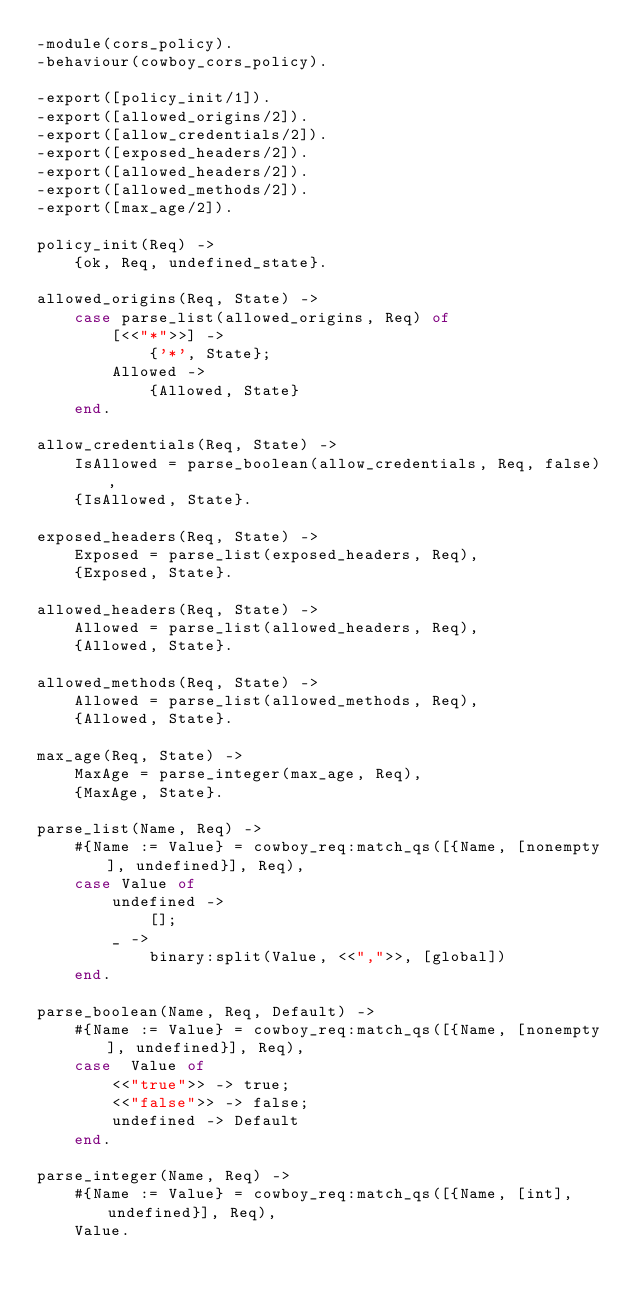<code> <loc_0><loc_0><loc_500><loc_500><_Erlang_>-module(cors_policy).
-behaviour(cowboy_cors_policy).

-export([policy_init/1]).
-export([allowed_origins/2]).
-export([allow_credentials/2]).
-export([exposed_headers/2]).
-export([allowed_headers/2]).
-export([allowed_methods/2]).
-export([max_age/2]).

policy_init(Req) ->
    {ok, Req, undefined_state}.

allowed_origins(Req, State) ->
    case parse_list(allowed_origins, Req) of
        [<<"*">>] ->
            {'*', State};
        Allowed ->
            {Allowed, State}
    end.

allow_credentials(Req, State) ->
    IsAllowed = parse_boolean(allow_credentials, Req, false),
    {IsAllowed, State}.

exposed_headers(Req, State) ->
    Exposed = parse_list(exposed_headers, Req),
    {Exposed, State}.

allowed_headers(Req, State) ->
    Allowed = parse_list(allowed_headers, Req),
    {Allowed, State}.

allowed_methods(Req, State) ->
    Allowed = parse_list(allowed_methods, Req),
    {Allowed, State}.

max_age(Req, State) ->
    MaxAge = parse_integer(max_age, Req),
    {MaxAge, State}.

parse_list(Name, Req) ->
    #{Name := Value} = cowboy_req:match_qs([{Name, [nonempty], undefined}], Req),
    case Value of
        undefined ->
            [];
        _ ->
            binary:split(Value, <<",">>, [global])
    end.

parse_boolean(Name, Req, Default) ->
    #{Name := Value} = cowboy_req:match_qs([{Name, [nonempty], undefined}], Req),
    case  Value of
        <<"true">> -> true;
        <<"false">> -> false;
        undefined -> Default
    end.

parse_integer(Name, Req) ->
    #{Name := Value} = cowboy_req:match_qs([{Name, [int], undefined}], Req),
    Value.
</code> 